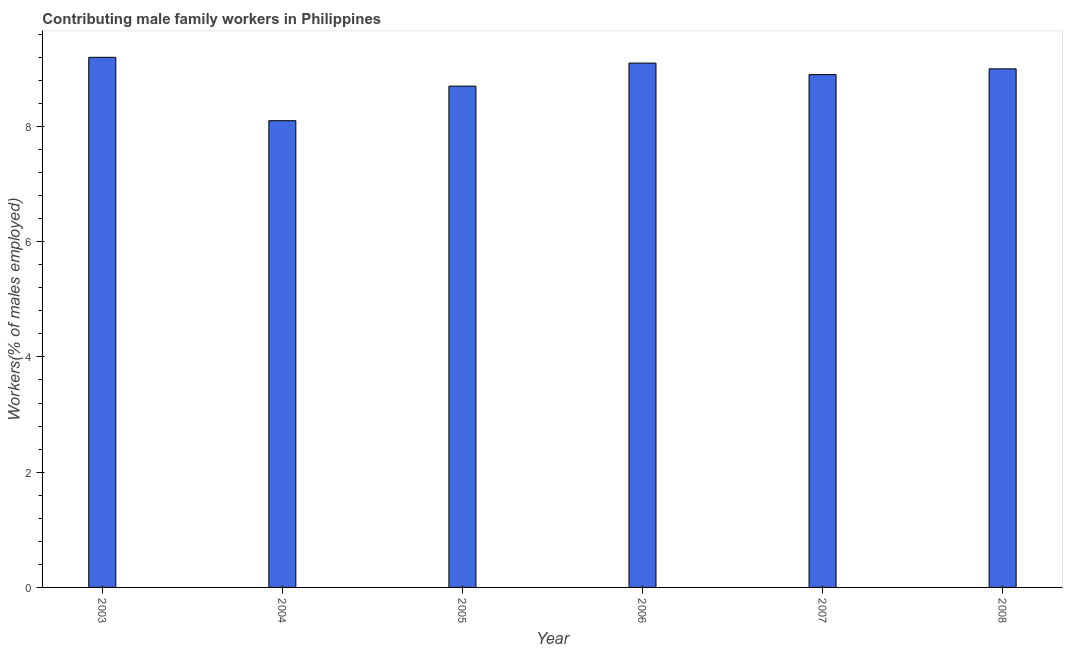What is the title of the graph?
Provide a succinct answer. Contributing male family workers in Philippines. What is the label or title of the X-axis?
Keep it short and to the point. Year. What is the label or title of the Y-axis?
Your response must be concise. Workers(% of males employed). What is the contributing male family workers in 2007?
Make the answer very short. 8.9. Across all years, what is the maximum contributing male family workers?
Your response must be concise. 9.2. Across all years, what is the minimum contributing male family workers?
Offer a very short reply. 8.1. In which year was the contributing male family workers maximum?
Your response must be concise. 2003. What is the sum of the contributing male family workers?
Your response must be concise. 53. What is the average contributing male family workers per year?
Your answer should be very brief. 8.83. What is the median contributing male family workers?
Offer a terse response. 8.95. Do a majority of the years between 2006 and 2007 (inclusive) have contributing male family workers greater than 3.2 %?
Offer a terse response. Yes. What is the ratio of the contributing male family workers in 2004 to that in 2005?
Provide a short and direct response. 0.93. Is the contributing male family workers in 2003 less than that in 2005?
Your answer should be compact. No. In how many years, is the contributing male family workers greater than the average contributing male family workers taken over all years?
Keep it short and to the point. 4. Are all the bars in the graph horizontal?
Provide a succinct answer. No. How many years are there in the graph?
Make the answer very short. 6. Are the values on the major ticks of Y-axis written in scientific E-notation?
Give a very brief answer. No. What is the Workers(% of males employed) of 2003?
Your response must be concise. 9.2. What is the Workers(% of males employed) of 2004?
Offer a very short reply. 8.1. What is the Workers(% of males employed) of 2005?
Provide a short and direct response. 8.7. What is the Workers(% of males employed) in 2006?
Provide a succinct answer. 9.1. What is the Workers(% of males employed) of 2007?
Your response must be concise. 8.9. What is the difference between the Workers(% of males employed) in 2003 and 2005?
Make the answer very short. 0.5. What is the difference between the Workers(% of males employed) in 2003 and 2007?
Keep it short and to the point. 0.3. What is the difference between the Workers(% of males employed) in 2003 and 2008?
Make the answer very short. 0.2. What is the difference between the Workers(% of males employed) in 2004 and 2006?
Provide a short and direct response. -1. What is the difference between the Workers(% of males employed) in 2004 and 2008?
Provide a short and direct response. -0.9. What is the difference between the Workers(% of males employed) in 2005 and 2006?
Your answer should be compact. -0.4. What is the difference between the Workers(% of males employed) in 2005 and 2007?
Keep it short and to the point. -0.2. What is the difference between the Workers(% of males employed) in 2005 and 2008?
Make the answer very short. -0.3. What is the difference between the Workers(% of males employed) in 2006 and 2007?
Make the answer very short. 0.2. What is the difference between the Workers(% of males employed) in 2006 and 2008?
Ensure brevity in your answer.  0.1. What is the ratio of the Workers(% of males employed) in 2003 to that in 2004?
Your response must be concise. 1.14. What is the ratio of the Workers(% of males employed) in 2003 to that in 2005?
Your answer should be compact. 1.06. What is the ratio of the Workers(% of males employed) in 2003 to that in 2007?
Provide a succinct answer. 1.03. What is the ratio of the Workers(% of males employed) in 2004 to that in 2005?
Ensure brevity in your answer.  0.93. What is the ratio of the Workers(% of males employed) in 2004 to that in 2006?
Offer a very short reply. 0.89. What is the ratio of the Workers(% of males employed) in 2004 to that in 2007?
Ensure brevity in your answer.  0.91. What is the ratio of the Workers(% of males employed) in 2005 to that in 2006?
Make the answer very short. 0.96. What is the ratio of the Workers(% of males employed) in 2005 to that in 2008?
Provide a succinct answer. 0.97. What is the ratio of the Workers(% of males employed) in 2006 to that in 2008?
Ensure brevity in your answer.  1.01. 